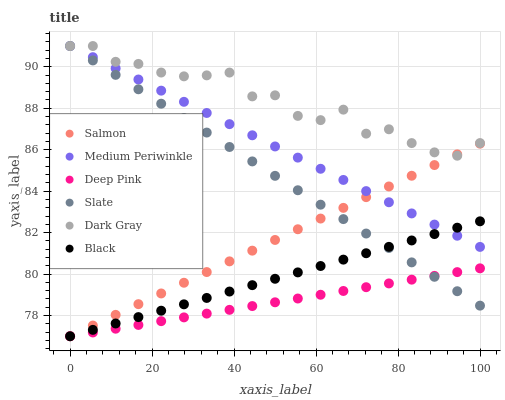Does Deep Pink have the minimum area under the curve?
Answer yes or no. Yes. Does Dark Gray have the maximum area under the curve?
Answer yes or no. Yes. Does Salmon have the minimum area under the curve?
Answer yes or no. No. Does Salmon have the maximum area under the curve?
Answer yes or no. No. Is Slate the smoothest?
Answer yes or no. Yes. Is Dark Gray the roughest?
Answer yes or no. Yes. Is Salmon the smoothest?
Answer yes or no. No. Is Salmon the roughest?
Answer yes or no. No. Does Deep Pink have the lowest value?
Answer yes or no. Yes. Does Slate have the lowest value?
Answer yes or no. No. Does Dark Gray have the highest value?
Answer yes or no. Yes. Does Salmon have the highest value?
Answer yes or no. No. Is Deep Pink less than Dark Gray?
Answer yes or no. Yes. Is Medium Periwinkle greater than Deep Pink?
Answer yes or no. Yes. Does Slate intersect Medium Periwinkle?
Answer yes or no. Yes. Is Slate less than Medium Periwinkle?
Answer yes or no. No. Is Slate greater than Medium Periwinkle?
Answer yes or no. No. Does Deep Pink intersect Dark Gray?
Answer yes or no. No. 